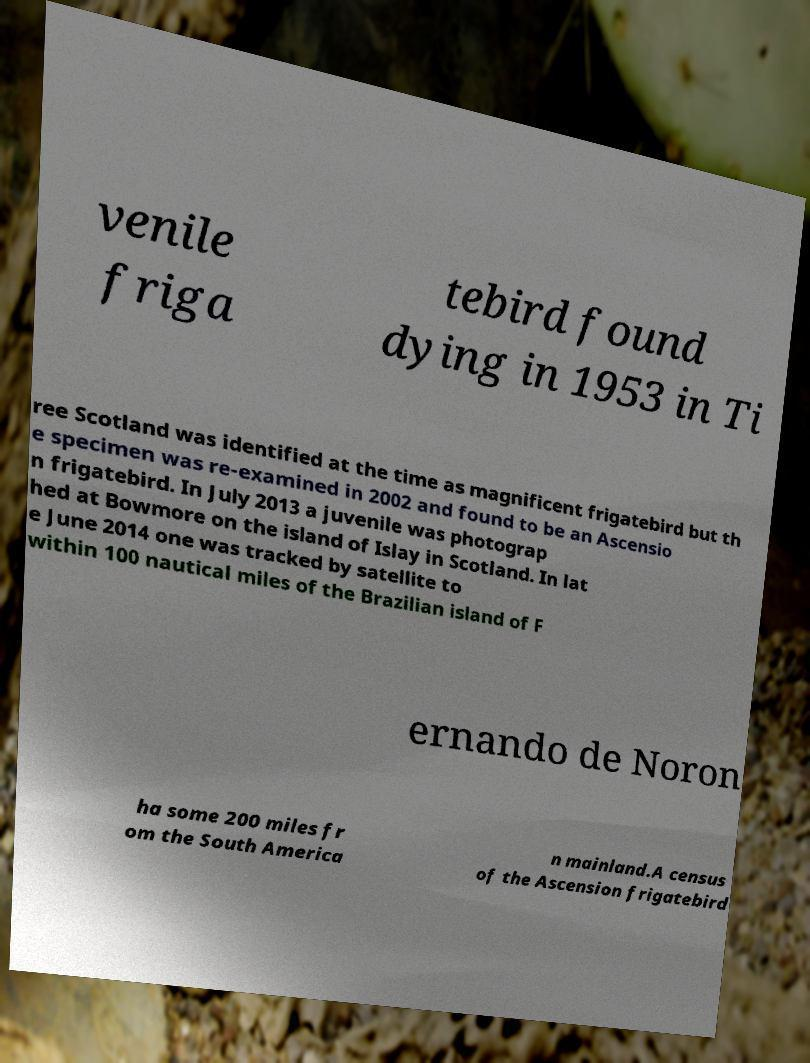Could you extract and type out the text from this image? venile friga tebird found dying in 1953 in Ti ree Scotland was identified at the time as magnificent frigatebird but th e specimen was re-examined in 2002 and found to be an Ascensio n frigatebird. In July 2013 a juvenile was photograp hed at Bowmore on the island of Islay in Scotland. In lat e June 2014 one was tracked by satellite to within 100 nautical miles of the Brazilian island of F ernando de Noron ha some 200 miles fr om the South America n mainland.A census of the Ascension frigatebird 